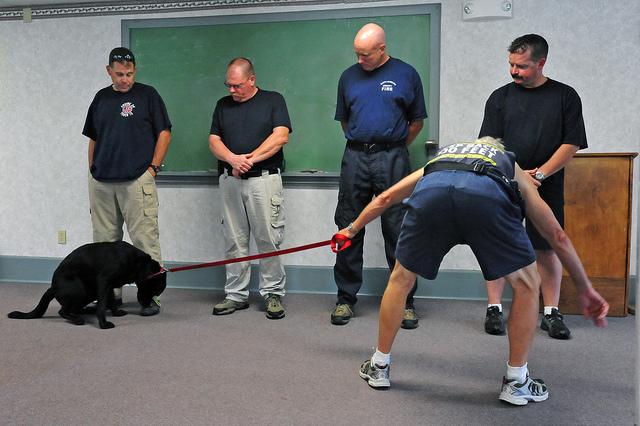How many people in shorts?
Answer briefly. 2. Are the men in the photo looking up?
Short answer required. No. What are they trying to teach the dog?
Short answer required. Walk. 